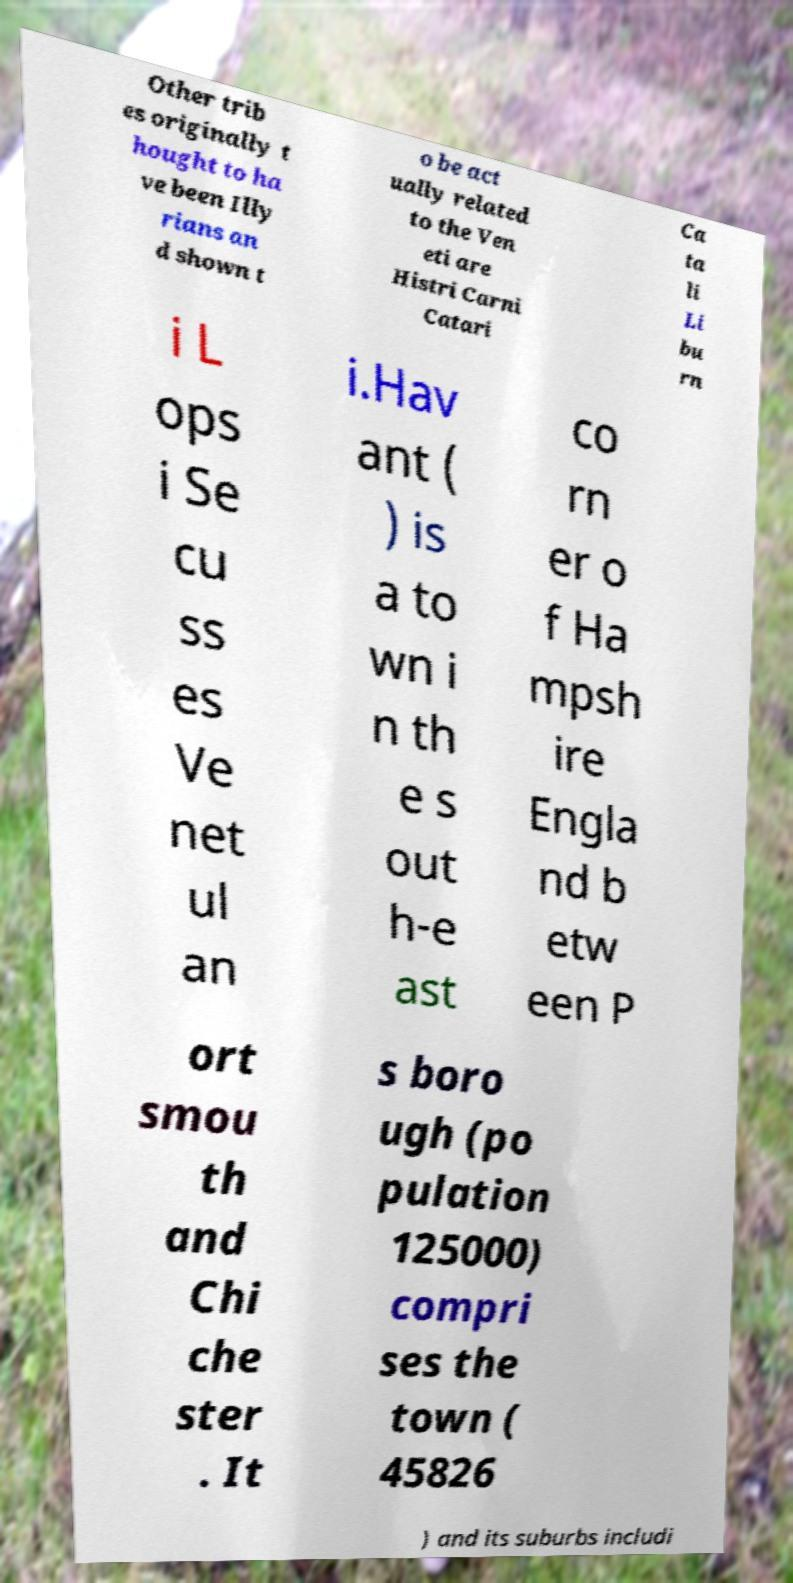Could you assist in decoding the text presented in this image and type it out clearly? Other trib es originally t hought to ha ve been Illy rians an d shown t o be act ually related to the Ven eti are Histri Carni Catari Ca ta li Li bu rn i L ops i Se cu ss es Ve net ul an i.Hav ant ( ) is a to wn i n th e s out h-e ast co rn er o f Ha mpsh ire Engla nd b etw een P ort smou th and Chi che ster . It s boro ugh (po pulation 125000) compri ses the town ( 45826 ) and its suburbs includi 